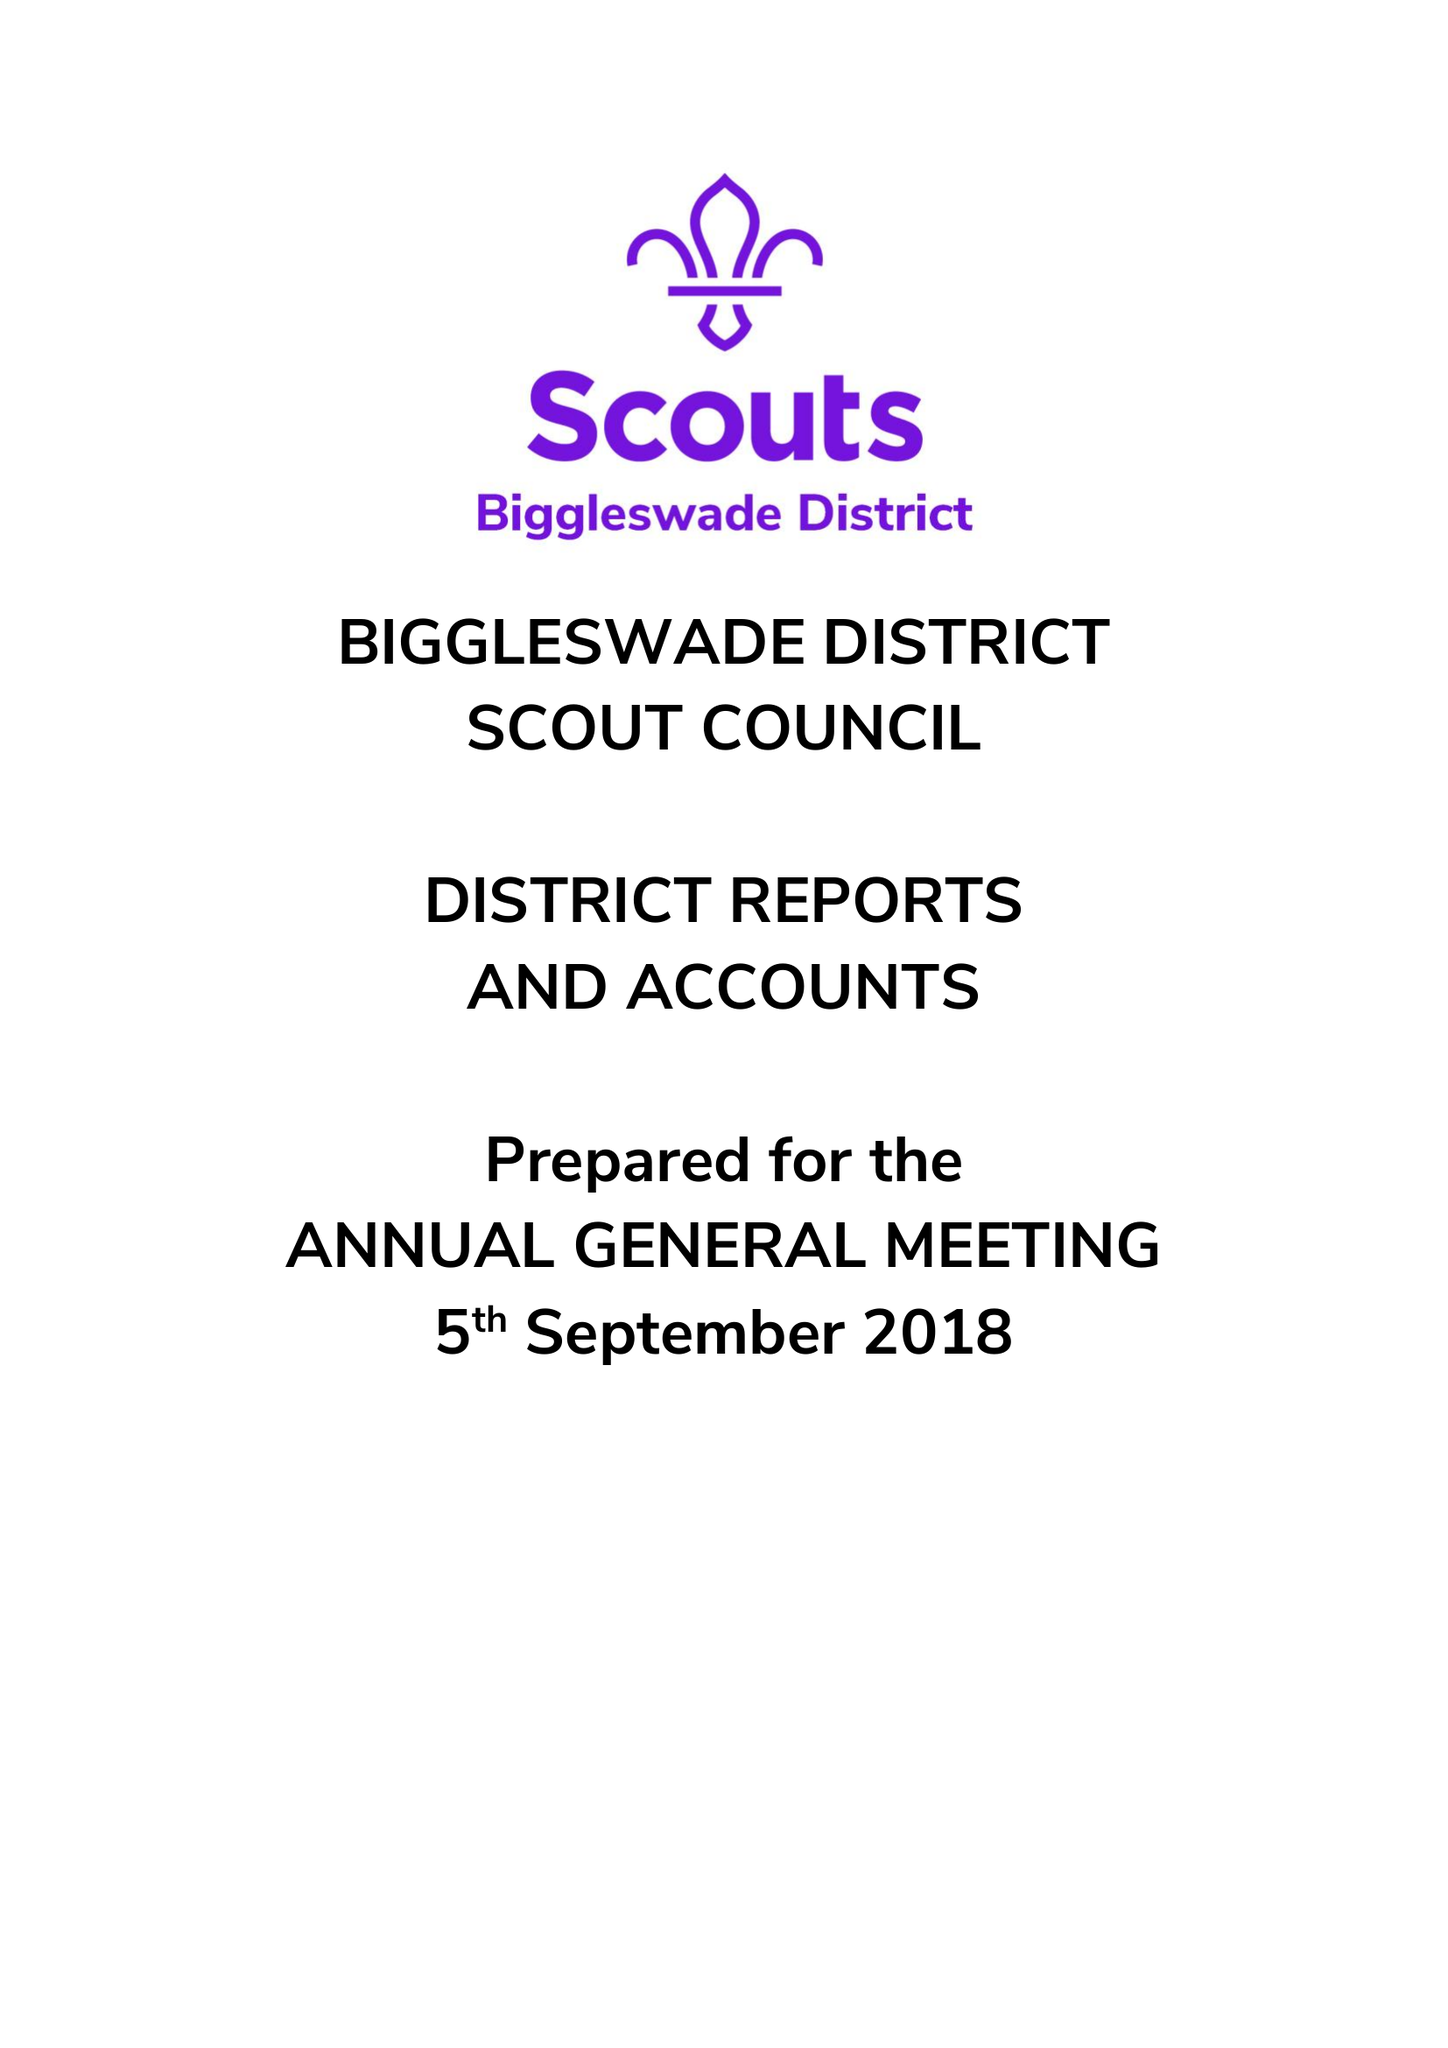What is the value for the report_date?
Answer the question using a single word or phrase. 2017-12-31 